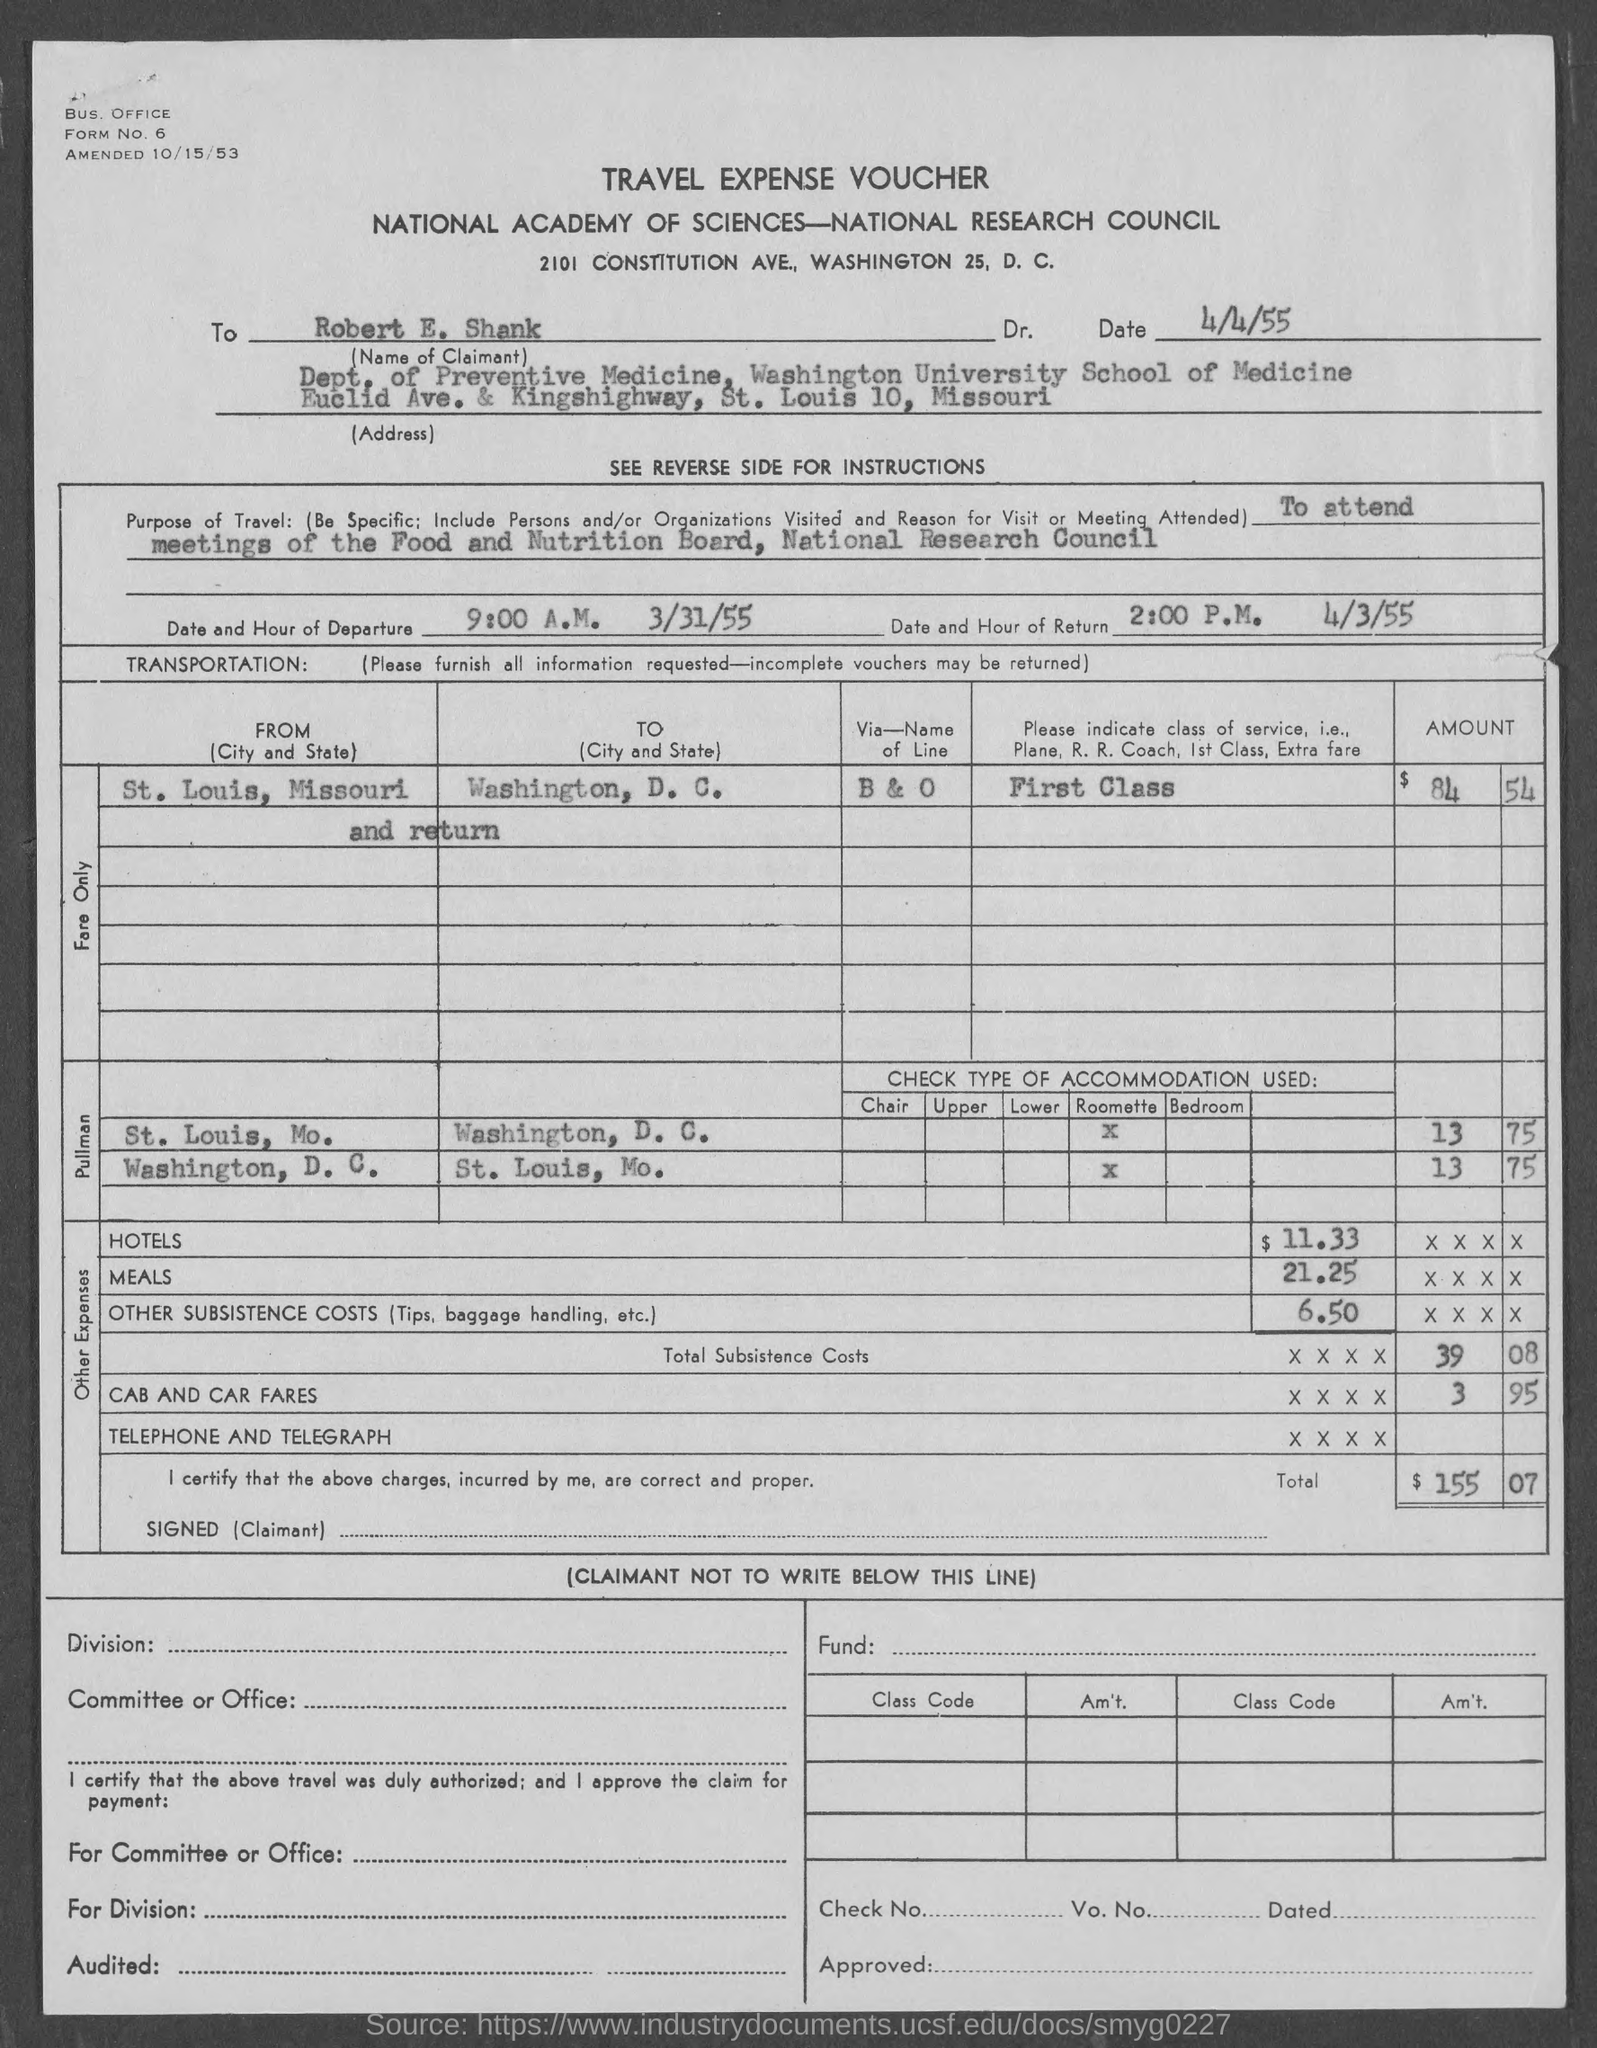What is the form no.?
Provide a succinct answer. 6. What is the name of the claimant ?
Make the answer very short. ROBERT E. SHANK. What is the date of departure ?
Give a very brief answer. 3/31/55. What is the date of return?
Offer a very short reply. 4/3/55. What is the hour of departure?
Offer a terse response. 9:00 A.M. What is the hour of return ?
Keep it short and to the point. 2:00 P.M. 